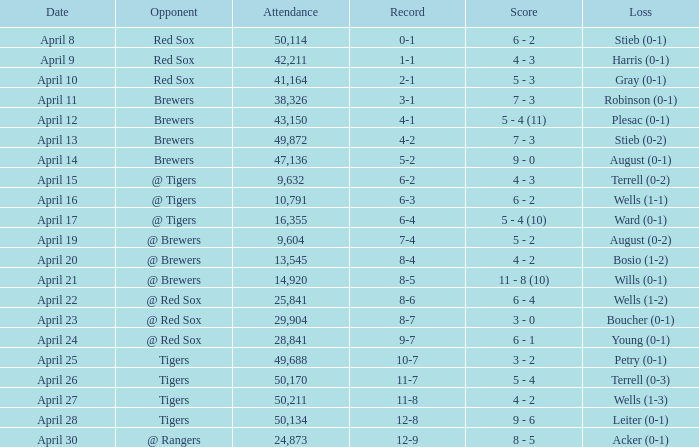Which rival has a decrease in wells numbering between 1 and 3? Tigers. 